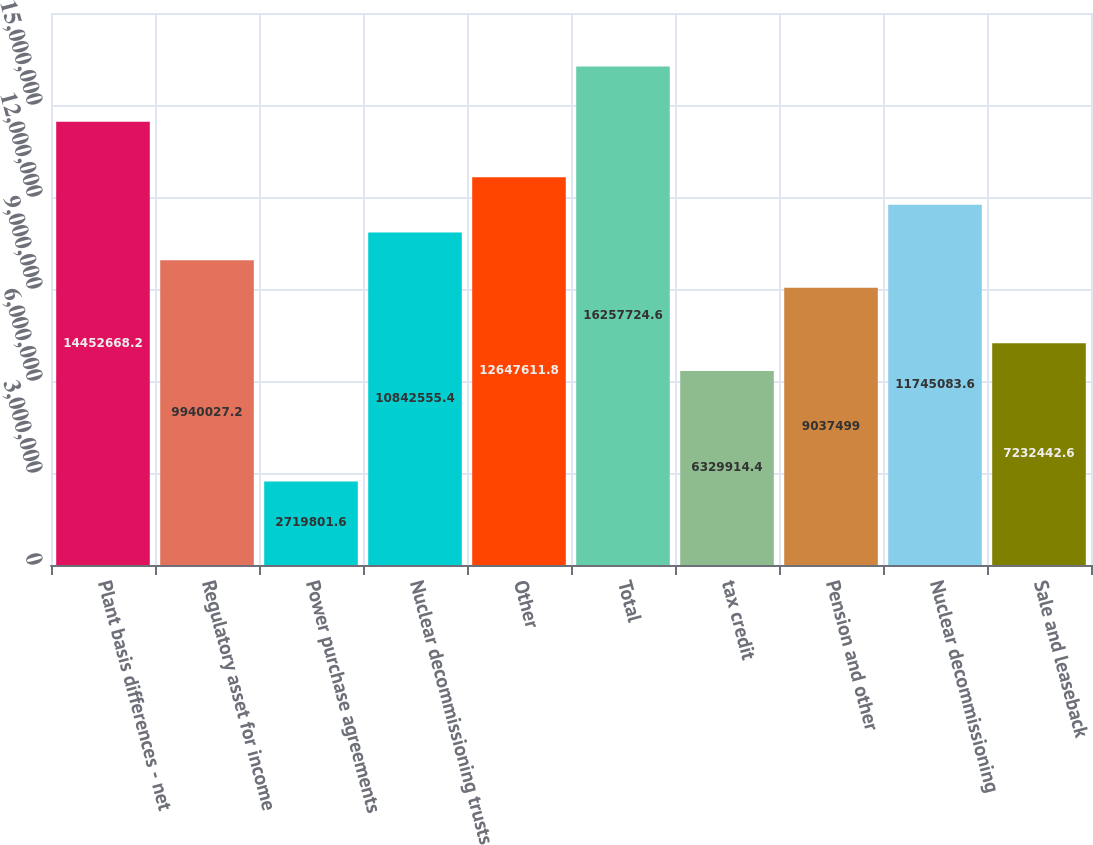Convert chart. <chart><loc_0><loc_0><loc_500><loc_500><bar_chart><fcel>Plant basis differences - net<fcel>Regulatory asset for income<fcel>Power purchase agreements<fcel>Nuclear decommissioning trusts<fcel>Other<fcel>Total<fcel>tax credit<fcel>Pension and other<fcel>Nuclear decommissioning<fcel>Sale and leaseback<nl><fcel>1.44527e+07<fcel>9.94003e+06<fcel>2.7198e+06<fcel>1.08426e+07<fcel>1.26476e+07<fcel>1.62577e+07<fcel>6.32991e+06<fcel>9.0375e+06<fcel>1.17451e+07<fcel>7.23244e+06<nl></chart> 